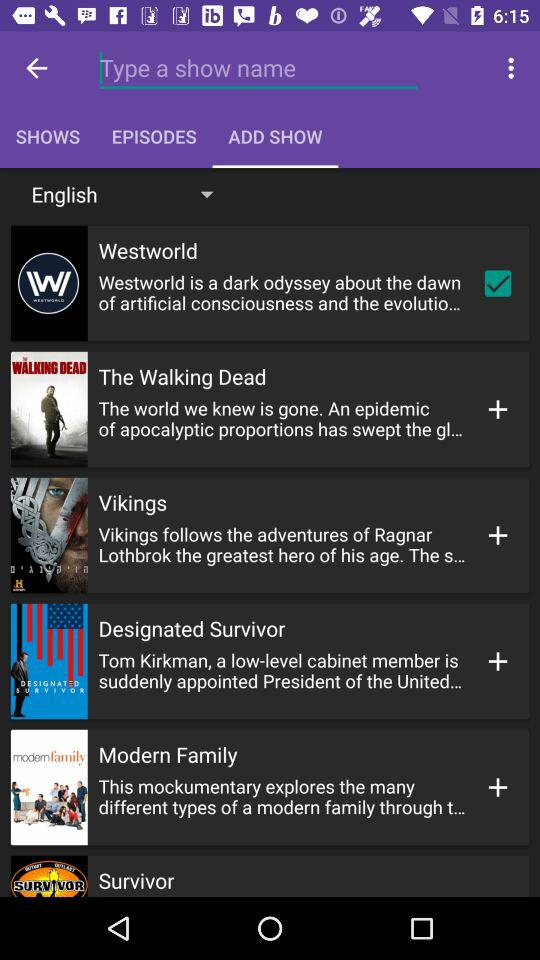Which language is selected? The selected language is English. 